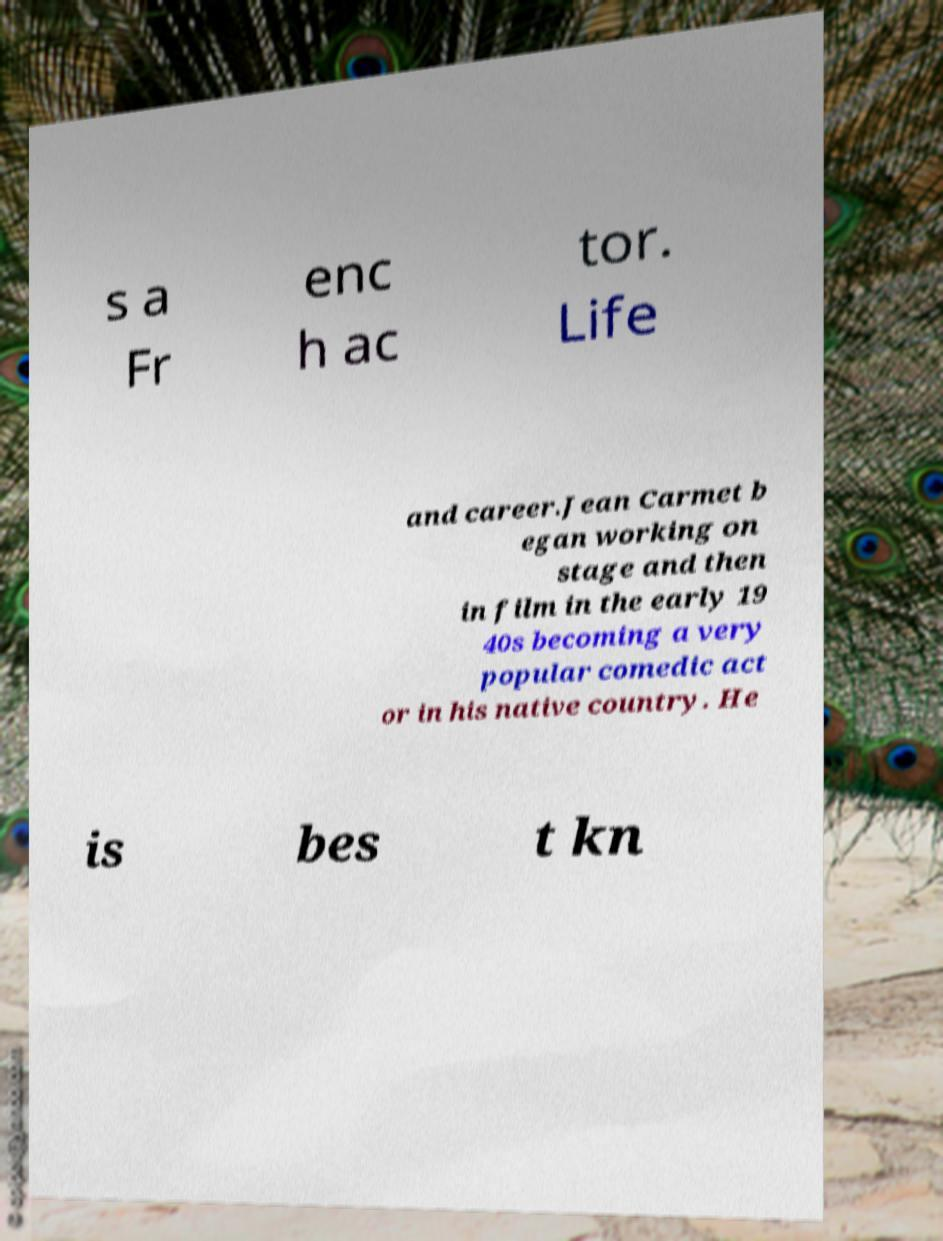What messages or text are displayed in this image? I need them in a readable, typed format. s a Fr enc h ac tor. Life and career.Jean Carmet b egan working on stage and then in film in the early 19 40s becoming a very popular comedic act or in his native country. He is bes t kn 